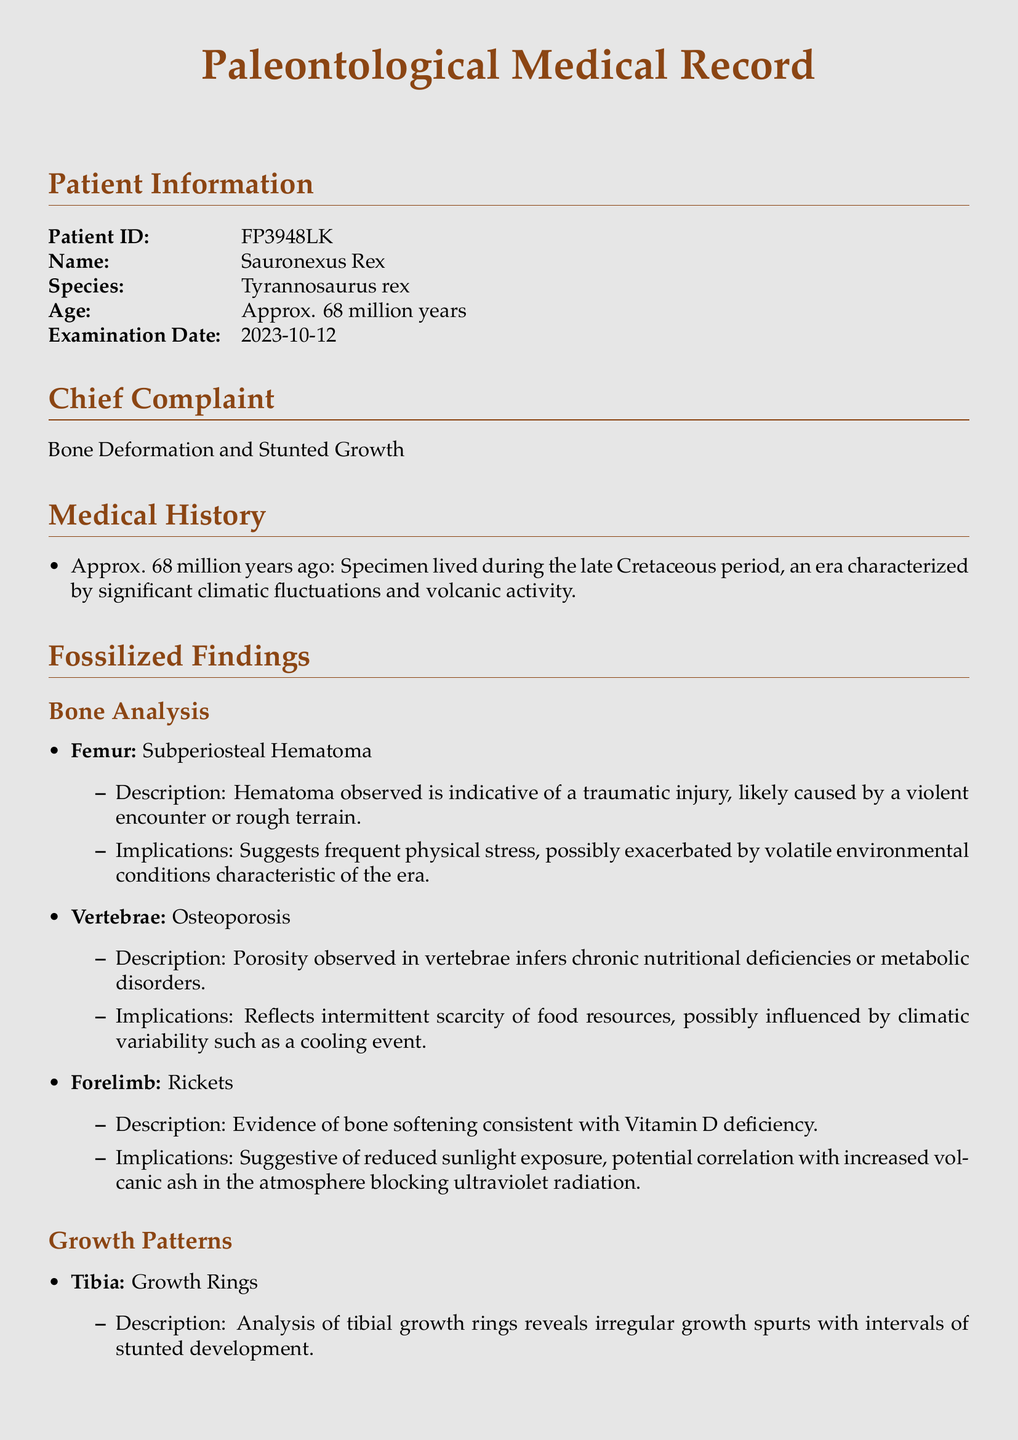What is the Patient ID? The Patient ID is presented in the document as a unique identifier for the specimen.
Answer: FP3948LK What species does Sauronexus Rex belong to? The document specifies the species associated with the specimen in the patient information section.
Answer: Tyrannosaurus rex What is described in the chief complaint? The chief complaint outlines the primary issues faced by the specimen, detailed in a concise statement.
Answer: Bone Deformation and Stunted Growth What climatic event is suggested to impact the nutritional deficiencies? The document notes a climatic variability event that likely influenced the specimen’s health and nutrient intake.
Answer: Cooling event What bone pathology indicates chronic nutritional deficiencies? The document describes certain conditions identified in the bone analysis that signify longer-term health issues.
Answer: Osteoporosis What were the observed implications of irregular growth spurts in the tibia? The implications trace back to environmental factors influencing growth patterns during specific climatic conditions.
Answer: Climatic instability What does the presence of rickets suggest about the specimen’s environment? The document highlights a specific deficiency related to environmental exposure affecting vitamin absorption and bone health.
Answer: Reduced sunlight exposure What is the major conclusion drawn from the findings in the document? The conclusion summarizes the overall relationship noted between the specimen's health and the ancient climate variability documented.
Answer: Climate variability and bone pathologies correlation 